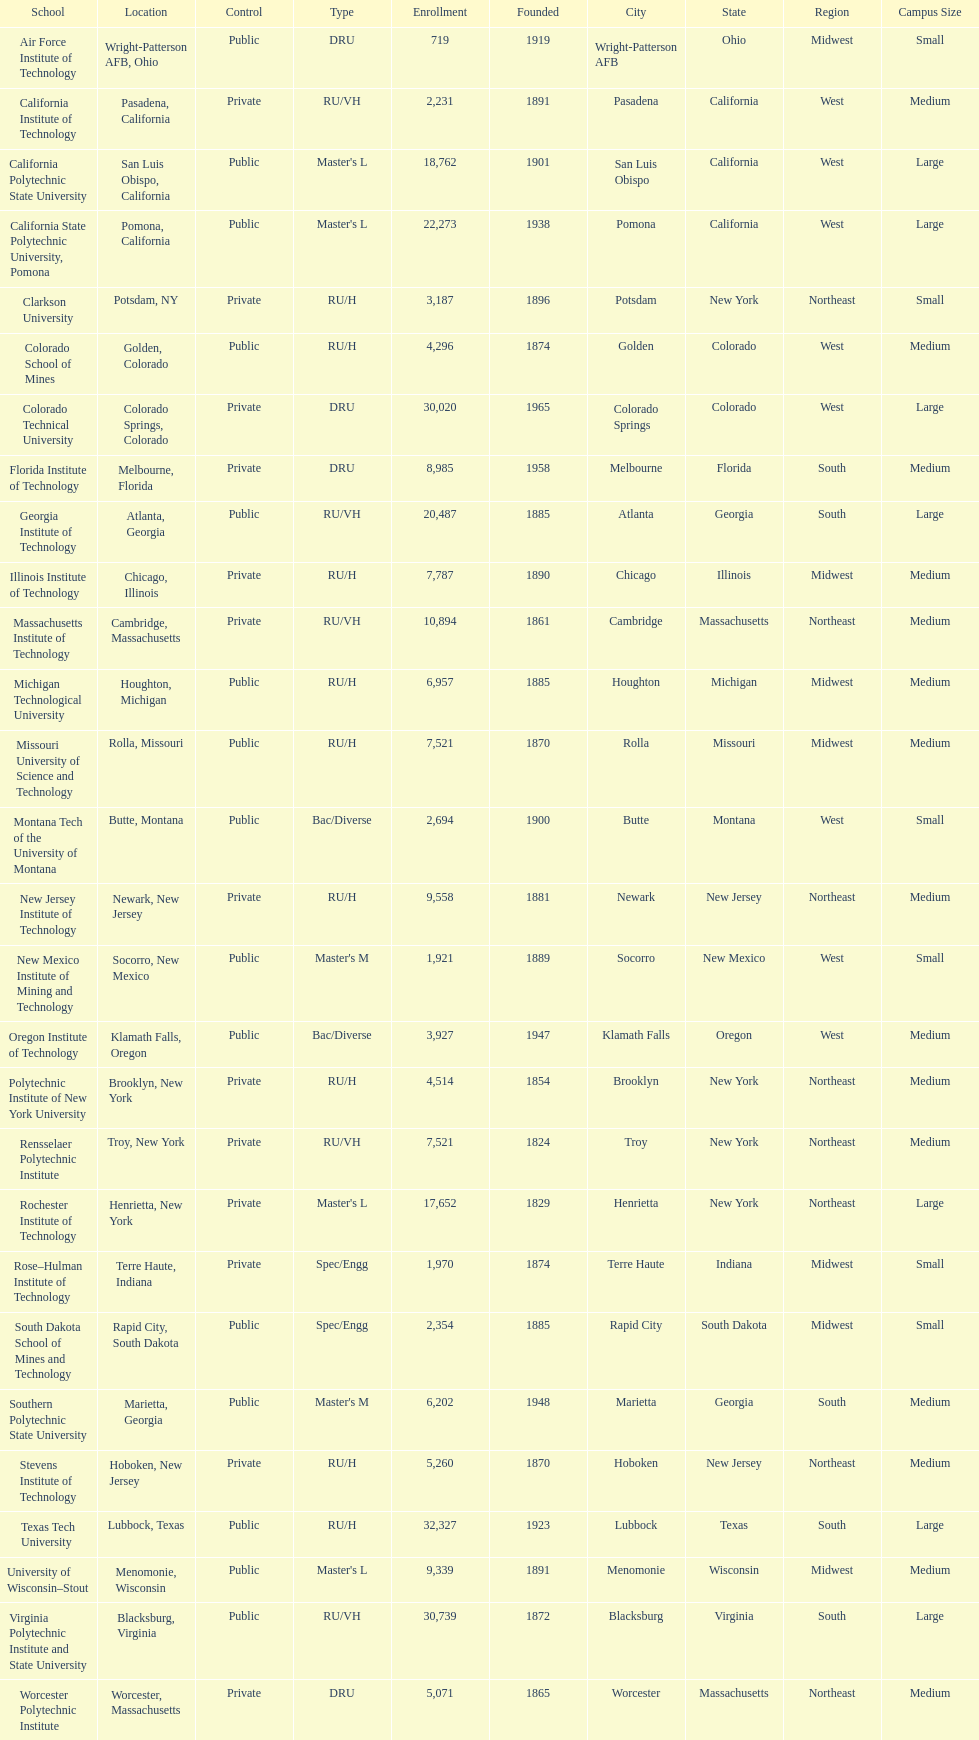What's the number of schools represented in the table? 28. 